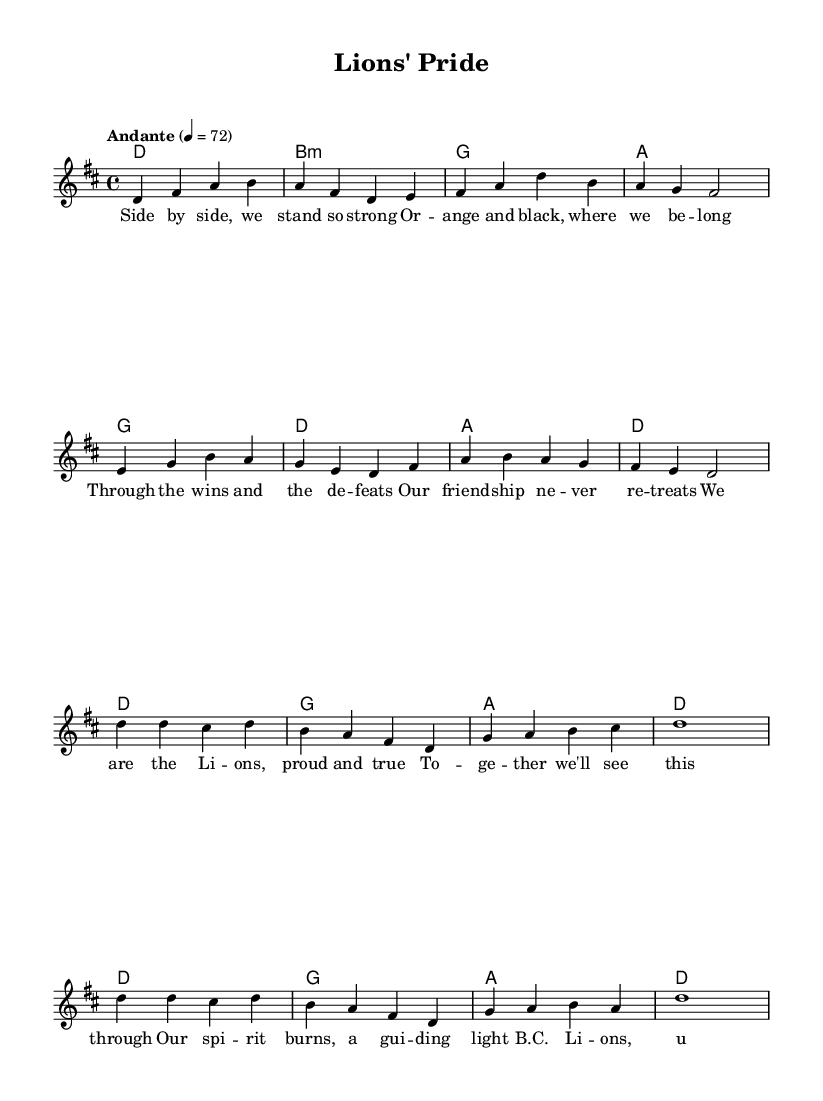What is the key signature of this music? The key signature is indicated by the number of sharps or flats at the beginning of the staff. In this case, it is D major, which has two sharps (F# and C#).
Answer: D major What is the time signature of this music? The time signature is found at the beginning of the music score and indicates the number of beats in each measure. Here, it is 4/4, which denotes four beats per measure.
Answer: 4/4 What is the tempo marking for this piece? The tempo marking is indicated above the staff with a speed indication. In this score, it shows "Andante" at a tempo of 72, which indicates a moderately slow pace.
Answer: Andante 72 How many phrases are in the chorus? The chorus consists of the musical segments where the melody and lyrics repeat a specific theme. In this score, by counting the number of distinct lines in the chorus lyrics, we find that it has four phrases.
Answer: Four What are the first two words of the verse? The first two words of the verse can be identified from the lyrics placed under the melody notes. Here, they are "Side by."
Answer: Side by What is the last line of the chorus? To find the last line of the chorus, one looks at the lyrics associated with the melody in the chorus section. The final line is "united we fight."
Answer: united we fight What key element of K-Pop is featured prominently in this ballad? K-Pop ballads often emphasize emotional expressions of friendship and unity, as seen in this piece's theme centered around loyalty and team spirit, showcased through both lyrics and melodic structure.
Answer: Friendship and unity 